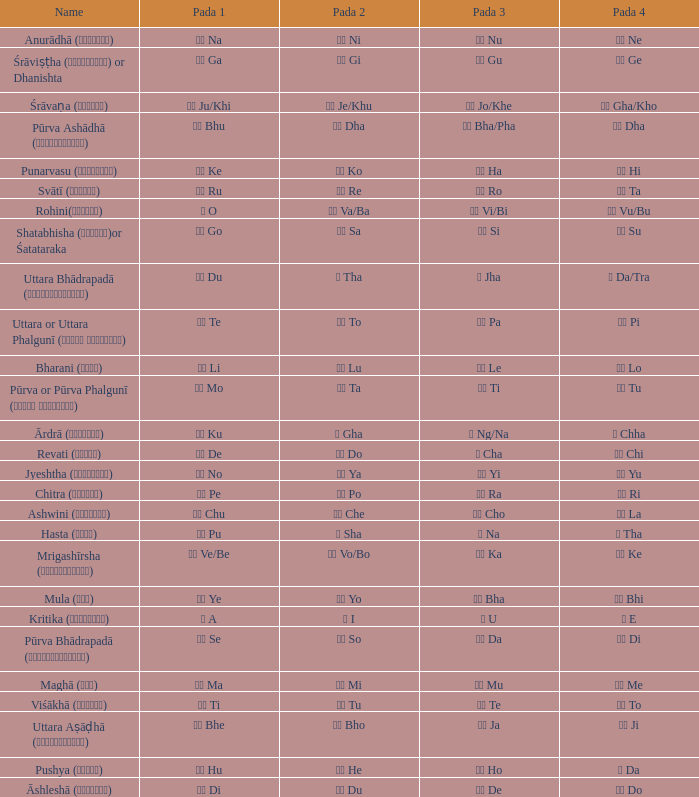What kind of Pada 1 has a Pada 2 of सा sa? गो Go. Can you parse all the data within this table? {'header': ['Name', 'Pada 1', 'Pada 2', 'Pada 3', 'Pada 4'], 'rows': [['Anurādhā (अनुराधा)', 'ना Na', 'नी Ni', 'नू Nu', 'ने Ne'], ['Śrāviṣṭha (श्रविष्ठा) or Dhanishta', 'गा Ga', 'गी Gi', 'गु Gu', 'गे Ge'], ['Śrāvaṇa (श्र\u200cावण)', 'खी Ju/Khi', 'खू Je/Khu', 'खे Jo/Khe', 'खो Gha/Kho'], ['Pūrva Ashādhā (पूर्वाषाढ़ा)', 'भू Bhu', 'धा Dha', 'फा Bha/Pha', 'ढा Dha'], ['Punarvasu (पुनर्वसु)', 'के Ke', 'को Ko', 'हा Ha', 'ही Hi'], ['Svātī (स्वाति)', 'रू Ru', 'रे Re', 'रो Ro', 'ता Ta'], ['Rohini(रोहिणी)', 'ओ O', 'वा Va/Ba', 'वी Vi/Bi', 'वु Vu/Bu'], ['Shatabhisha (शतभिषा)or Śatataraka', 'गो Go', 'सा Sa', 'सी Si', 'सू Su'], ['Uttara Bhādrapadā (उत्तरभाद्रपदा)', 'दू Du', 'थ Tha', 'झ Jha', 'ञ Da/Tra'], ['Uttara or Uttara Phalgunī (उत्तर फाल्गुनी)', 'टे Te', 'टो To', 'पा Pa', 'पी Pi'], ['Bharani (भरणी)', 'ली Li', 'लू Lu', 'ले Le', 'लो Lo'], ['Pūrva or Pūrva Phalgunī (पूर्व फाल्गुनी)', 'नो Mo', 'टा Ta', 'टी Ti', 'टू Tu'], ['Ārdrā (आर्द्रा)', 'कु Ku', 'घ Gha', 'ङ Ng/Na', 'छ Chha'], ['Revati (रेवती)', 'दे De', 'दो Do', 'च Cha', 'ची Chi'], ['Jyeshtha (ज्येष्ठा)', 'नो No', 'या Ya', 'यी Yi', 'यू Yu'], ['Chitra (चित्रा)', 'पे Pe', 'पो Po', 'रा Ra', 'री Ri'], ['Ashwini (अश्विनि)', 'चु Chu', 'चे Che', 'चो Cho', 'ला La'], ['Hasta (हस्त)', 'पू Pu', 'ष Sha', 'ण Na', 'ठ Tha'], ['Mrigashīrsha (म्रृगशीर्षा)', 'वे Ve/Be', 'वो Vo/Bo', 'का Ka', 'की Ke'], ['Mula (मूल)', 'ये Ye', 'यो Yo', 'भा Bha', 'भी Bhi'], ['Kritika (कृत्तिका)', 'अ A', 'ई I', 'उ U', 'ए E'], ['Pūrva Bhādrapadā (पूर्वभाद्रपदा)', 'से Se', 'सो So', 'दा Da', 'दी Di'], ['Maghā (मघा)', 'मा Ma', 'मी Mi', 'मू Mu', 'मे Me'], ['Viśākhā (विशाखा)', 'ती Ti', 'तू Tu', 'ते Te', 'तो To'], ['Uttara Aṣāḍhā (उत्तराषाढ़ा)', 'भे Bhe', 'भो Bho', 'जा Ja', 'जी Ji'], ['Pushya (पुष्य)', 'हु Hu', 'हे He', 'हो Ho', 'ड Da'], ['Āshleshā (आश्लेषा)', 'डी Di', 'डू Du', 'डे De', 'डो Do']]} 